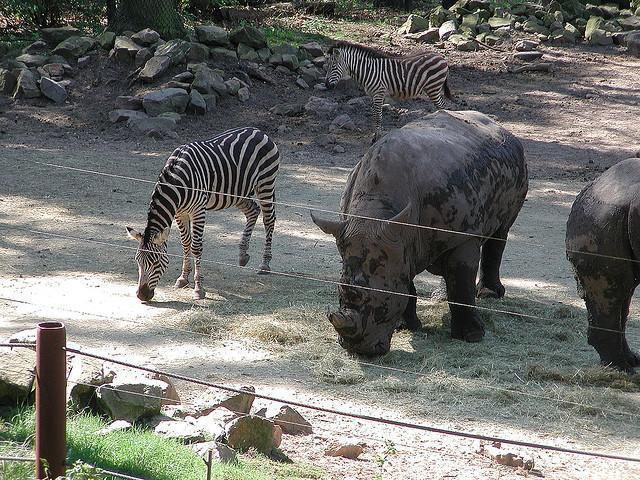How many types of animals are represented?
Give a very brief answer. 2. How many zebras are there?
Give a very brief answer. 2. 